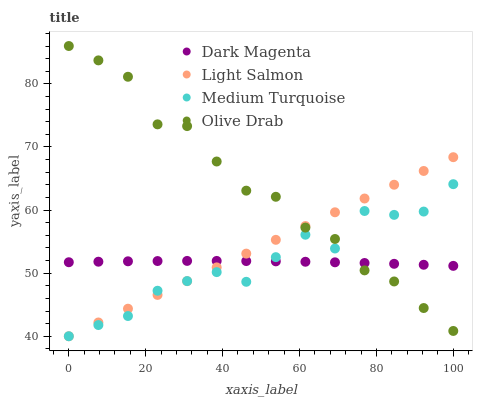Does Dark Magenta have the minimum area under the curve?
Answer yes or no. Yes. Does Olive Drab have the maximum area under the curve?
Answer yes or no. Yes. Does Light Salmon have the minimum area under the curve?
Answer yes or no. No. Does Light Salmon have the maximum area under the curve?
Answer yes or no. No. Is Light Salmon the smoothest?
Answer yes or no. Yes. Is Medium Turquoise the roughest?
Answer yes or no. Yes. Is Dark Magenta the smoothest?
Answer yes or no. No. Is Dark Magenta the roughest?
Answer yes or no. No. Does Light Salmon have the lowest value?
Answer yes or no. Yes. Does Dark Magenta have the lowest value?
Answer yes or no. No. Does Olive Drab have the highest value?
Answer yes or no. Yes. Does Light Salmon have the highest value?
Answer yes or no. No. Does Dark Magenta intersect Medium Turquoise?
Answer yes or no. Yes. Is Dark Magenta less than Medium Turquoise?
Answer yes or no. No. Is Dark Magenta greater than Medium Turquoise?
Answer yes or no. No. 